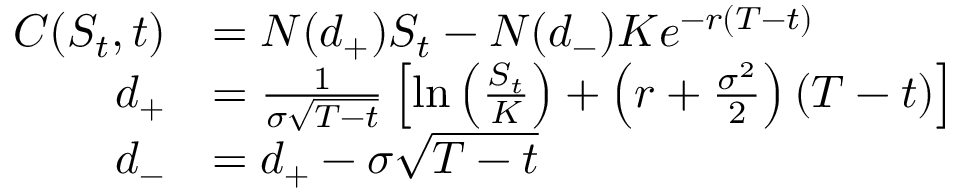Convert formula to latex. <formula><loc_0><loc_0><loc_500><loc_500>{ \begin{array} { r l } { C ( S _ { t } , t ) } & { = N ( d _ { + } ) S _ { t } - N ( d _ { - } ) K e ^ { - r ( T - t ) } } \\ { d _ { + } } & { = { \frac { 1 } { \sigma { \sqrt { T - t } } } } \left [ \ln \left ( { \frac { S _ { t } } { K } } \right ) + \left ( r + { \frac { \sigma ^ { 2 } } { 2 } } \right ) ( T - t ) \right ] } \\ { d _ { - } } & { = d _ { + } - \sigma { \sqrt { T - t } } } \end{array} }</formula> 